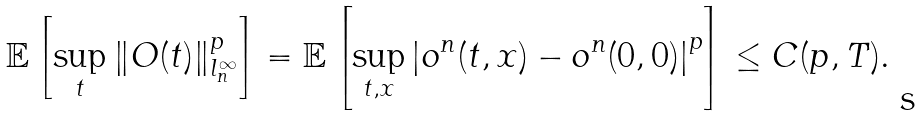Convert formula to latex. <formula><loc_0><loc_0><loc_500><loc_500>\mathbb { E } \left [ \sup _ { t } \| O ( t ) \| _ { l ^ { \infty } _ { n } } ^ { p } \right ] = \mathbb { E } \left [ \sup _ { t , x } \left | o ^ { n } ( t , x ) - o ^ { n } ( 0 , 0 ) \right | ^ { p } \right ] \leq C ( p , T ) .</formula> 